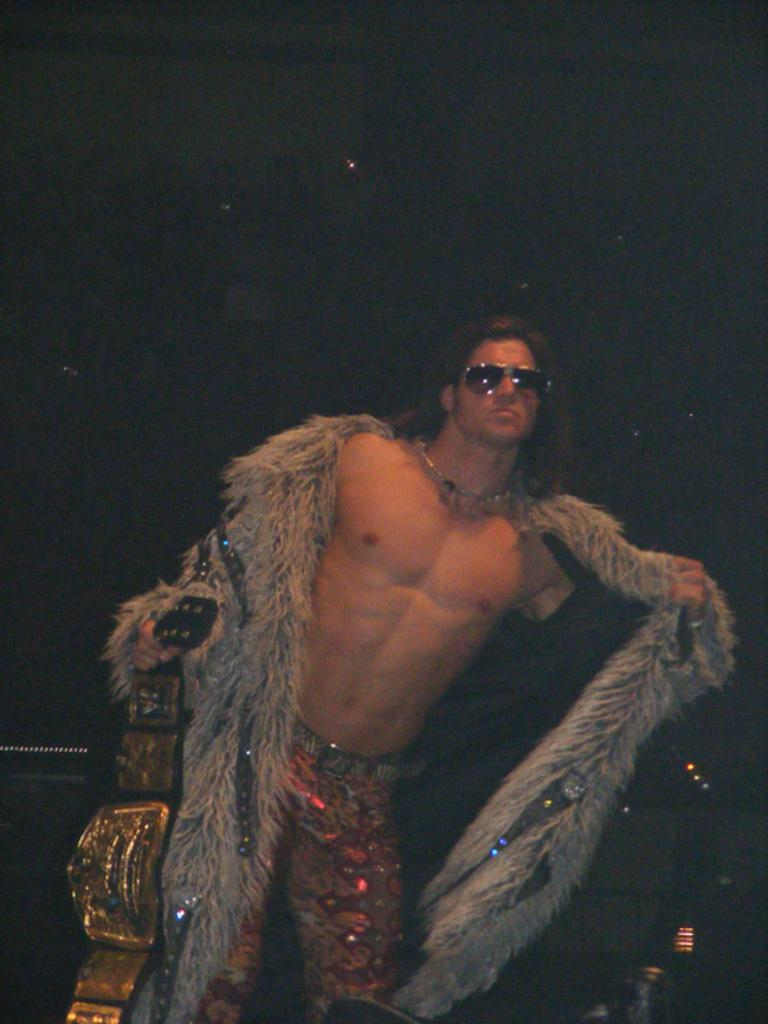Who is the main subject in the foreground of the image? There is a man in the foreground of the image. What is the man doing in the image? The man is standing in the image. What object is the man holding in his hand? The man is holding a gold belt in his hand. What can be observed about the background of the image? The background of the image is dark. What type of spark can be seen coming from the gold belt in the image? There is no spark visible in the image; the man is simply holding a gold belt in his hand. 